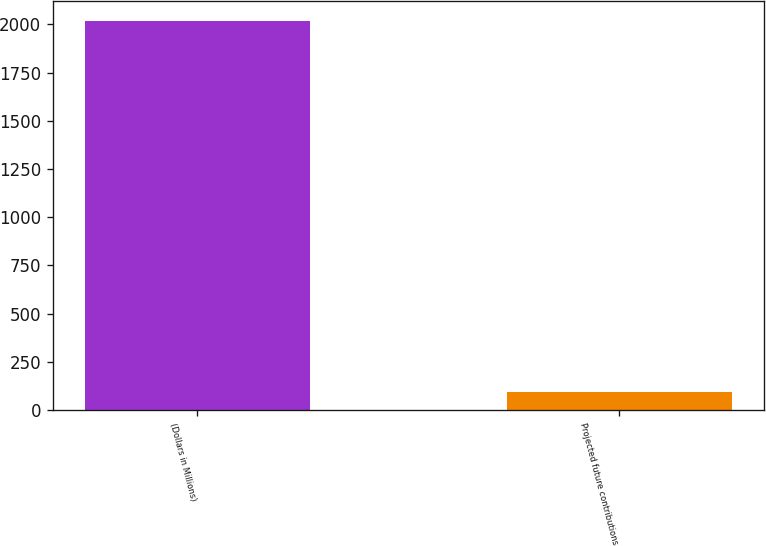<chart> <loc_0><loc_0><loc_500><loc_500><bar_chart><fcel>(Dollars in Millions)<fcel>Projected future contributions<nl><fcel>2020<fcel>95<nl></chart> 